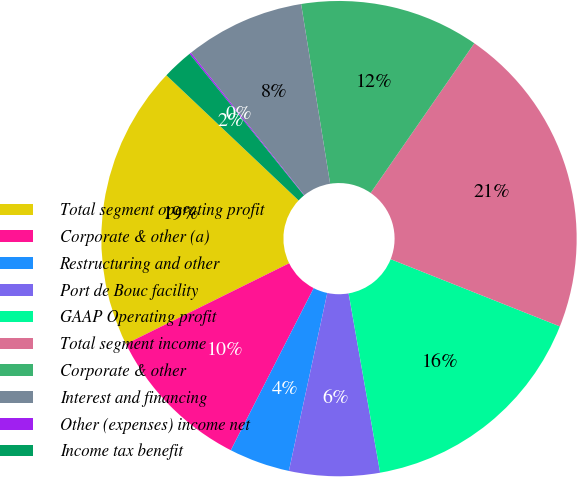<chart> <loc_0><loc_0><loc_500><loc_500><pie_chart><fcel>Total segment operating profit<fcel>Corporate & other (a)<fcel>Restructuring and other<fcel>Port de Bouc facility<fcel>GAAP Operating profit<fcel>Total segment income<fcel>Corporate & other<fcel>Interest and financing<fcel>Other (expenses) income net<fcel>Income tax benefit<nl><fcel>19.37%<fcel>10.17%<fcel>4.14%<fcel>6.15%<fcel>16.21%<fcel>21.38%<fcel>12.19%<fcel>8.16%<fcel>0.11%<fcel>2.12%<nl></chart> 